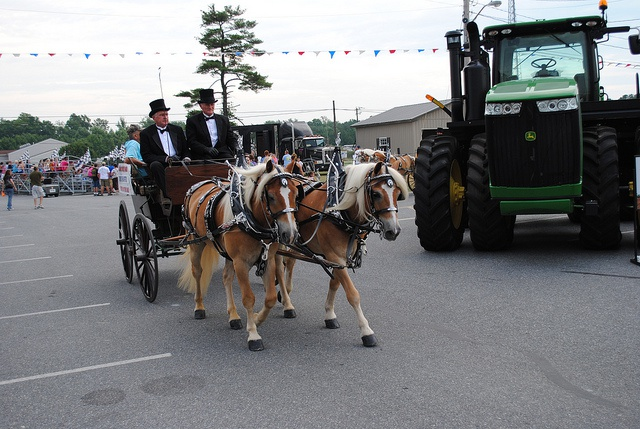Describe the objects in this image and their specific colors. I can see truck in white, black, teal, gray, and darkgray tones, horse in white, black, gray, maroon, and darkgray tones, people in white, darkgray, black, and gray tones, people in white, black, lavender, gray, and maroon tones, and people in white, black, lavender, darkgray, and maroon tones in this image. 